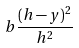Convert formula to latex. <formula><loc_0><loc_0><loc_500><loc_500>b { \frac { ( h - y ) ^ { 2 } } { h ^ { 2 } } }</formula> 